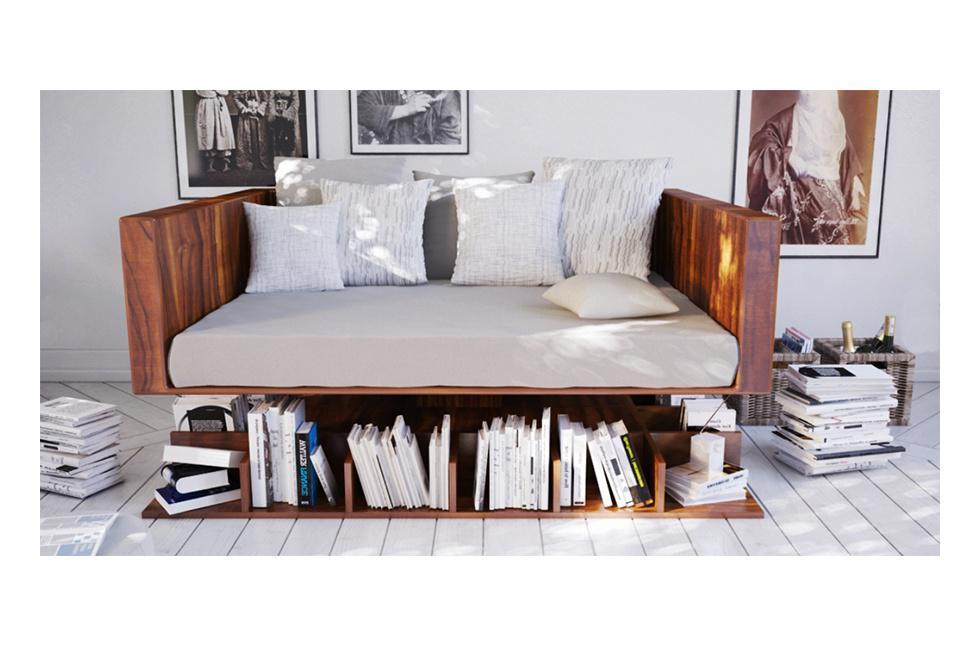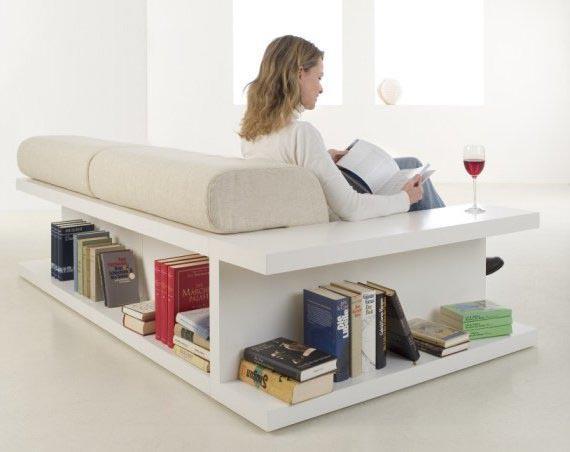The first image is the image on the left, the second image is the image on the right. Given the left and right images, does the statement "there is a bookself with a rug on a wood floor" hold true? Answer yes or no. No. 